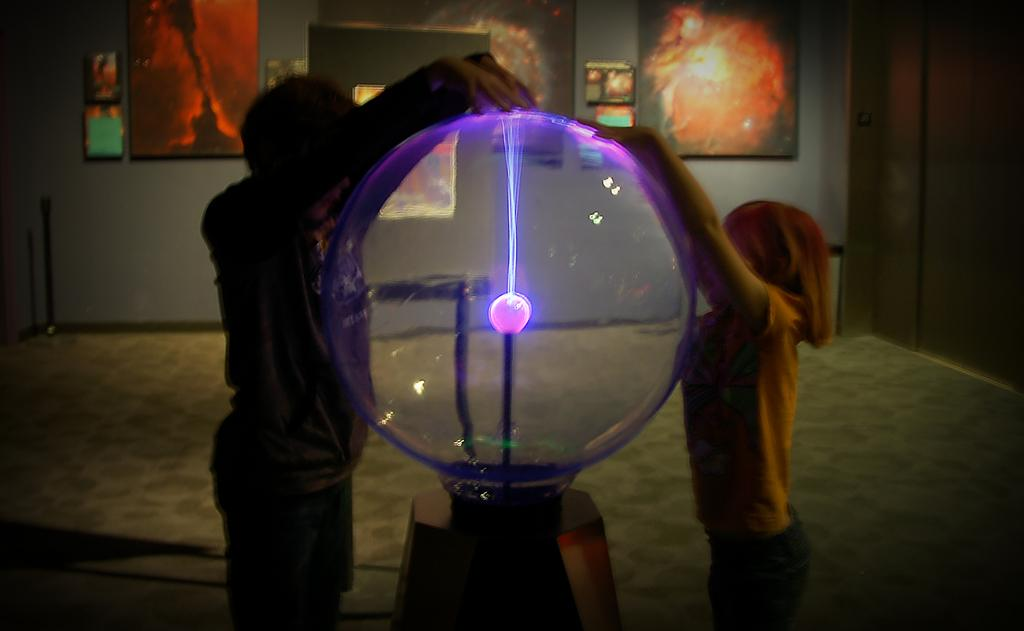Who are the two people in the image? There is a boy and a girl in the image. Where are the boy and girl located in the image? They are in the center of the image. What are the boy and girl doing in the image? They are placing their hands on a colorful ball. What can be seen on the wall in the image? There are portraits on the wall in the image. Where are the portraits located in the image? The portraits are at the top side of the image. What type of insect can be seen crawling on the wire in the image? There is no insect or wire present in the image. How many sheep are visible in the image? There are no sheep present in the image. 